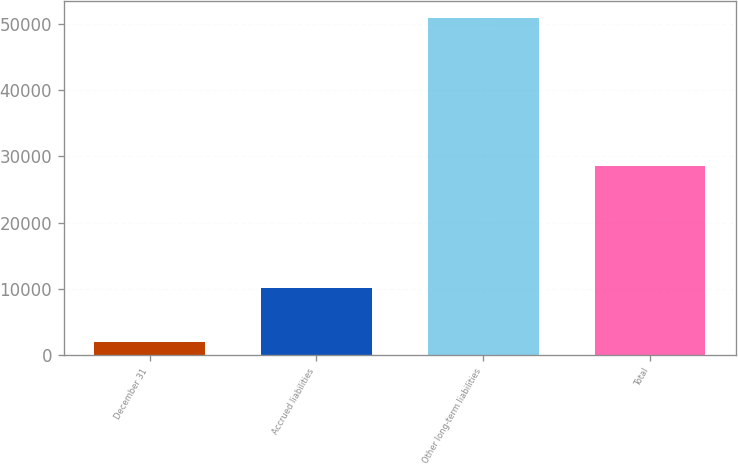Convert chart. <chart><loc_0><loc_0><loc_500><loc_500><bar_chart><fcel>December 31<fcel>Accrued liabilities<fcel>Other long-term liabilities<fcel>Total<nl><fcel>2013<fcel>10198<fcel>50842<fcel>28507<nl></chart> 